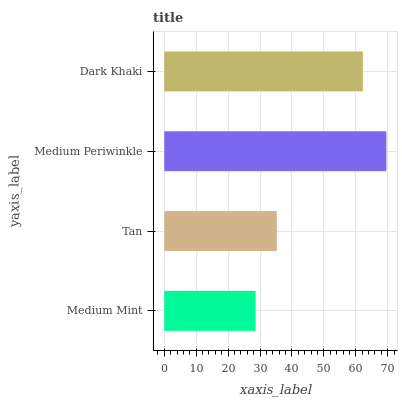Is Medium Mint the minimum?
Answer yes or no. Yes. Is Medium Periwinkle the maximum?
Answer yes or no. Yes. Is Tan the minimum?
Answer yes or no. No. Is Tan the maximum?
Answer yes or no. No. Is Tan greater than Medium Mint?
Answer yes or no. Yes. Is Medium Mint less than Tan?
Answer yes or no. Yes. Is Medium Mint greater than Tan?
Answer yes or no. No. Is Tan less than Medium Mint?
Answer yes or no. No. Is Dark Khaki the high median?
Answer yes or no. Yes. Is Tan the low median?
Answer yes or no. Yes. Is Medium Periwinkle the high median?
Answer yes or no. No. Is Medium Mint the low median?
Answer yes or no. No. 